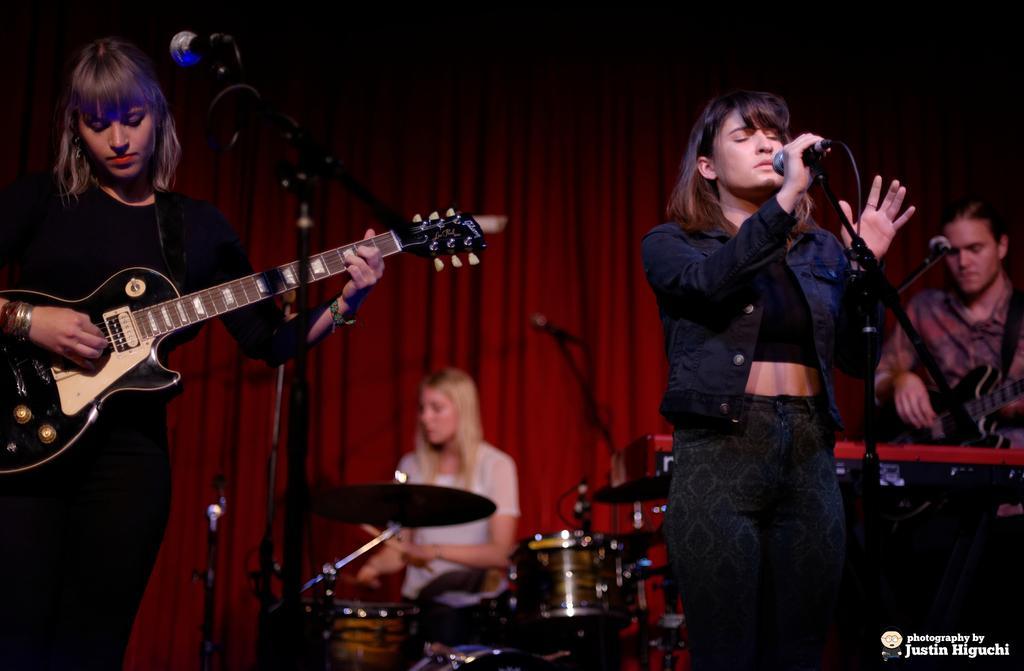Please provide a concise description of this image. In this picture there are group of people those who are performing the music event on the stage there is a girl who is standing at the left side of the image she is holding the guitar in her hands, there is a girl who is sitting at the center of the image she is playing the drums and there is a red color curtain behind them. 